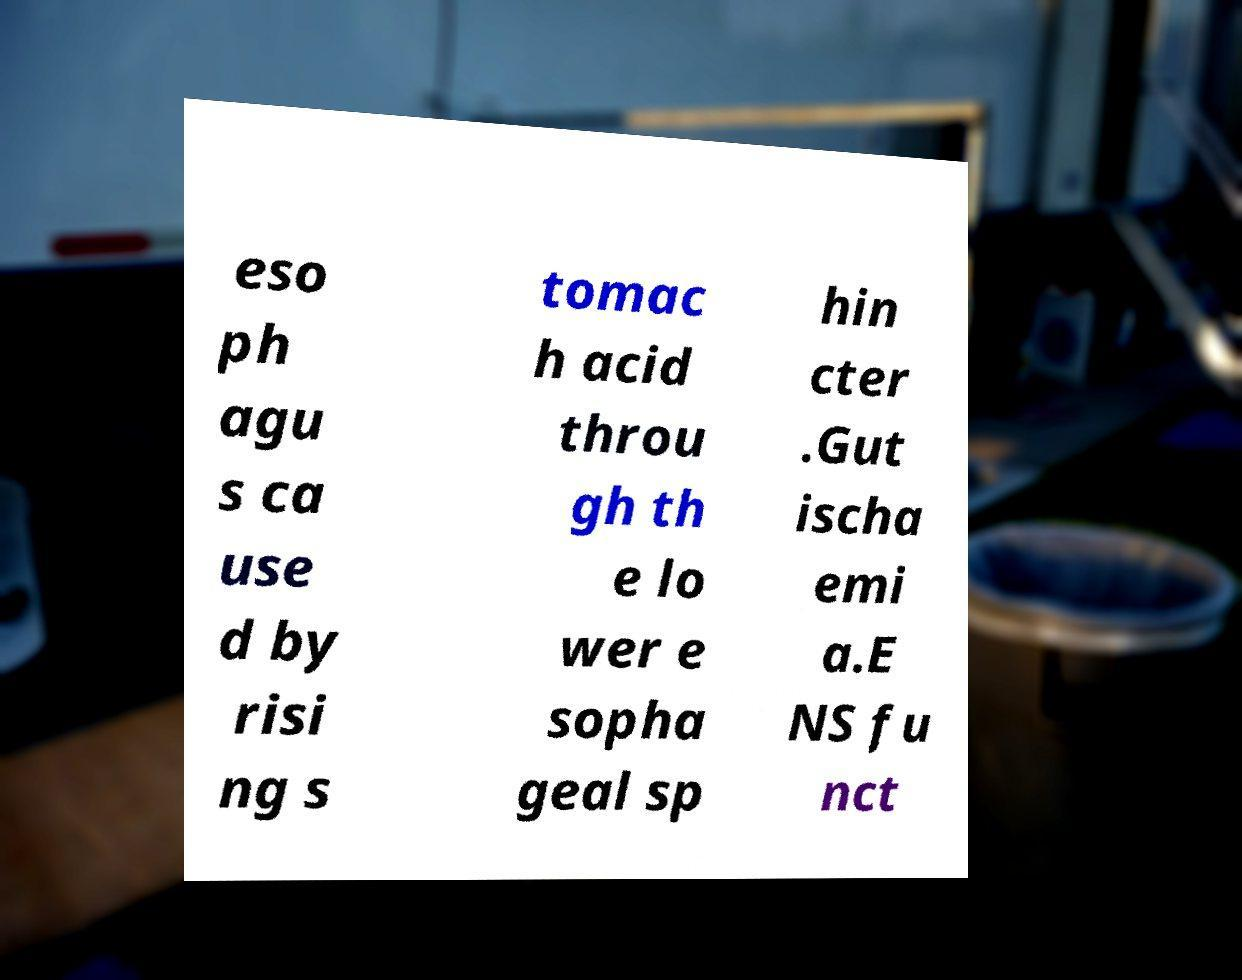There's text embedded in this image that I need extracted. Can you transcribe it verbatim? eso ph agu s ca use d by risi ng s tomac h acid throu gh th e lo wer e sopha geal sp hin cter .Gut ischa emi a.E NS fu nct 